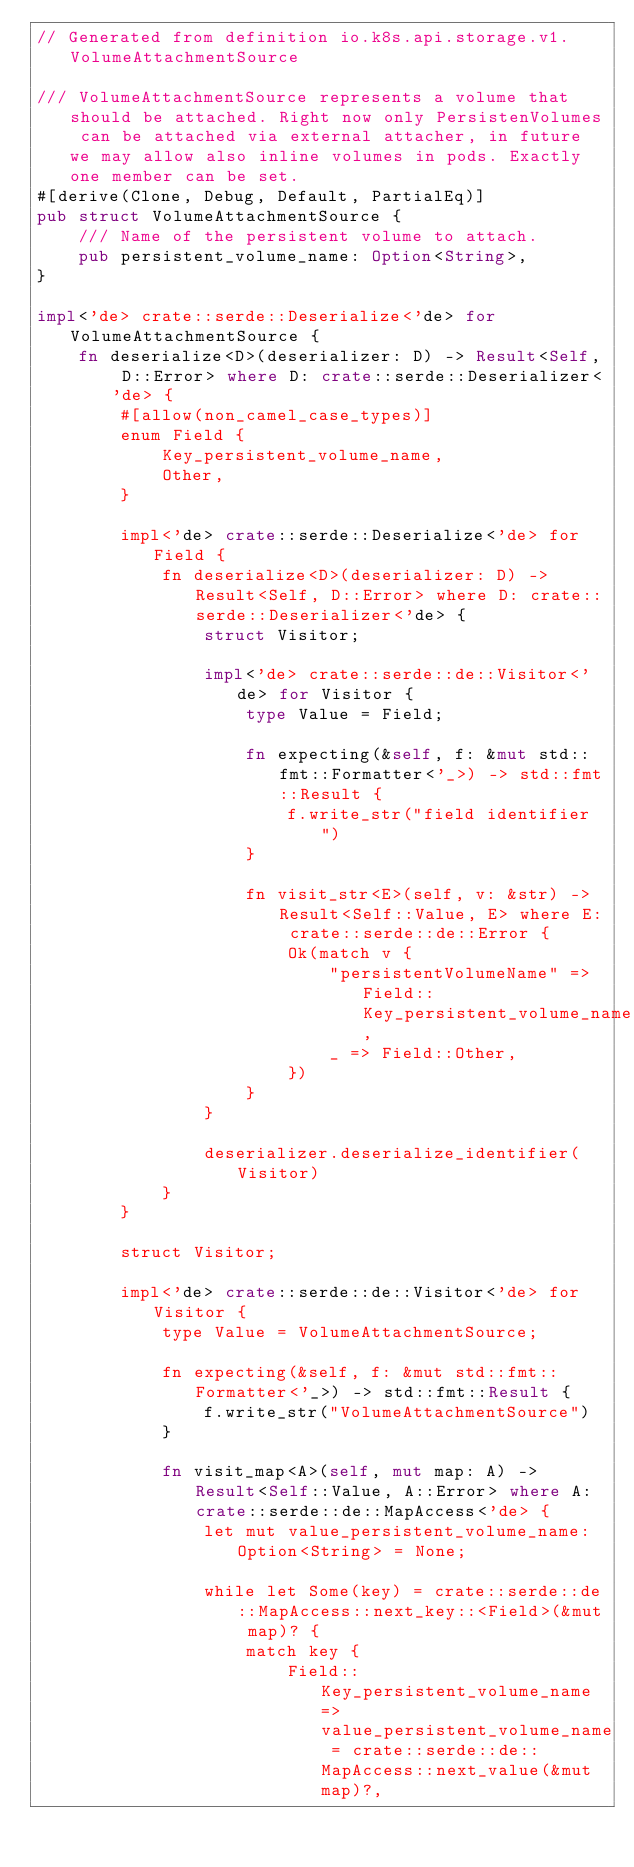Convert code to text. <code><loc_0><loc_0><loc_500><loc_500><_Rust_>// Generated from definition io.k8s.api.storage.v1.VolumeAttachmentSource

/// VolumeAttachmentSource represents a volume that should be attached. Right now only PersistenVolumes can be attached via external attacher, in future we may allow also inline volumes in pods. Exactly one member can be set.
#[derive(Clone, Debug, Default, PartialEq)]
pub struct VolumeAttachmentSource {
    /// Name of the persistent volume to attach.
    pub persistent_volume_name: Option<String>,
}

impl<'de> crate::serde::Deserialize<'de> for VolumeAttachmentSource {
    fn deserialize<D>(deserializer: D) -> Result<Self, D::Error> where D: crate::serde::Deserializer<'de> {
        #[allow(non_camel_case_types)]
        enum Field {
            Key_persistent_volume_name,
            Other,
        }

        impl<'de> crate::serde::Deserialize<'de> for Field {
            fn deserialize<D>(deserializer: D) -> Result<Self, D::Error> where D: crate::serde::Deserializer<'de> {
                struct Visitor;

                impl<'de> crate::serde::de::Visitor<'de> for Visitor {
                    type Value = Field;

                    fn expecting(&self, f: &mut std::fmt::Formatter<'_>) -> std::fmt::Result {
                        f.write_str("field identifier")
                    }

                    fn visit_str<E>(self, v: &str) -> Result<Self::Value, E> where E: crate::serde::de::Error {
                        Ok(match v {
                            "persistentVolumeName" => Field::Key_persistent_volume_name,
                            _ => Field::Other,
                        })
                    }
                }

                deserializer.deserialize_identifier(Visitor)
            }
        }

        struct Visitor;

        impl<'de> crate::serde::de::Visitor<'de> for Visitor {
            type Value = VolumeAttachmentSource;

            fn expecting(&self, f: &mut std::fmt::Formatter<'_>) -> std::fmt::Result {
                f.write_str("VolumeAttachmentSource")
            }

            fn visit_map<A>(self, mut map: A) -> Result<Self::Value, A::Error> where A: crate::serde::de::MapAccess<'de> {
                let mut value_persistent_volume_name: Option<String> = None;

                while let Some(key) = crate::serde::de::MapAccess::next_key::<Field>(&mut map)? {
                    match key {
                        Field::Key_persistent_volume_name => value_persistent_volume_name = crate::serde::de::MapAccess::next_value(&mut map)?,</code> 